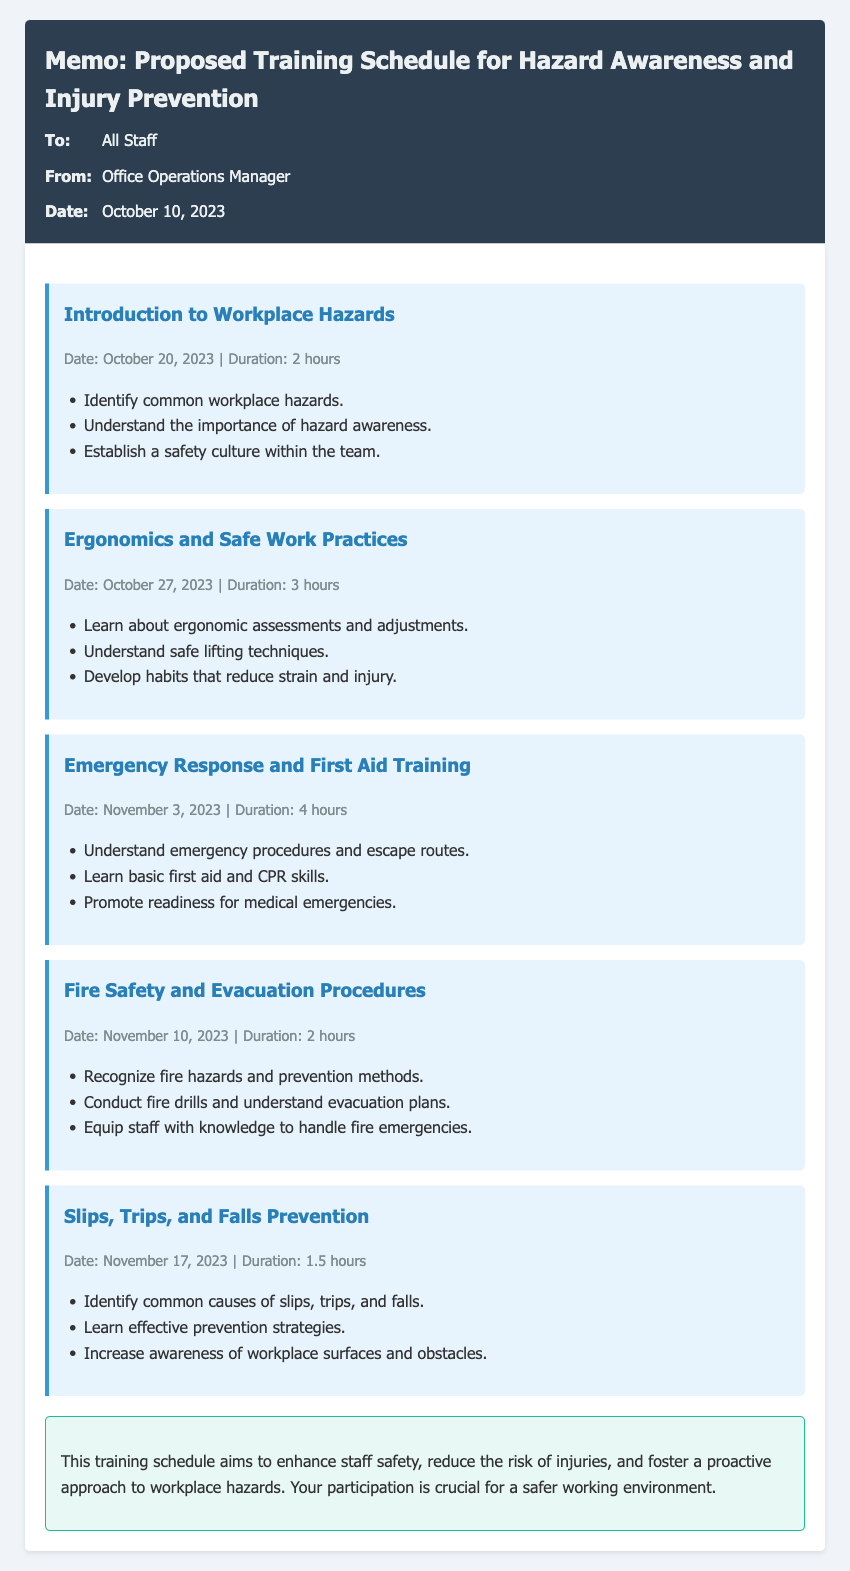What is the date of the first training session? The first training session, "Introduction to Workplace Hazards," is scheduled for October 20, 2023.
Answer: October 20, 2023 How long is the "Fire Safety and Evacuation Procedures" session? The duration of the "Fire Safety and Evacuation Procedures" session is mentioned to be 2 hours.
Answer: 2 hours What is the main focus of the "Emergency Response and First Aid Training"? The main focus includes understanding emergency procedures and basic first aid skills.
Answer: Emergency procedures and basic first aid skills How many total training sessions are included in the schedule? The schedule includes five separate training sessions related to hazards and injury prevention.
Answer: Five What is the expected outcome of the training sessions? The expected outcome is to enhance staff safety, reduce the risk of injuries, and foster a proactive approach to workplace hazards.
Answer: Enhance staff safety What session focuses on preventing slips and trips? The session titled "Slips, Trips, and Falls Prevention" focuses specifically on this aspect.
Answer: Slips, Trips, and Falls Prevention Which session discusses safe lifting techniques? The session dedicated to safe lifting techniques is "Ergonomics and Safe Work Practices."
Answer: Ergonomics and Safe Work Practices What does the conclusion of the memo emphasize? The conclusion emphasizes the importance of participation for a safer working environment.
Answer: Importance of participation 